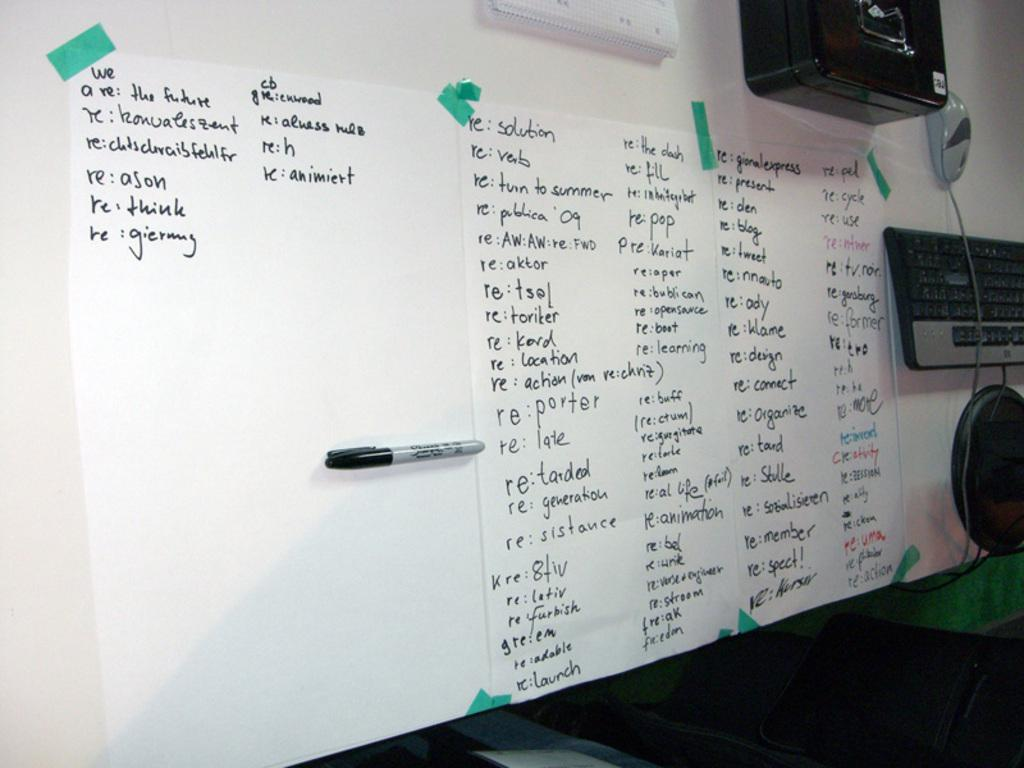<image>
Offer a succinct explanation of the picture presented. A white boards contans lists with the third column from he left beginning with solution. 